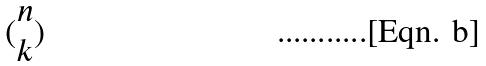Convert formula to latex. <formula><loc_0><loc_0><loc_500><loc_500>( \begin{matrix} n \\ k \end{matrix} )</formula> 